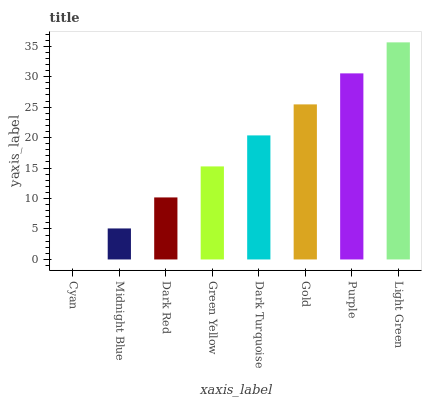Is Cyan the minimum?
Answer yes or no. Yes. Is Light Green the maximum?
Answer yes or no. Yes. Is Midnight Blue the minimum?
Answer yes or no. No. Is Midnight Blue the maximum?
Answer yes or no. No. Is Midnight Blue greater than Cyan?
Answer yes or no. Yes. Is Cyan less than Midnight Blue?
Answer yes or no. Yes. Is Cyan greater than Midnight Blue?
Answer yes or no. No. Is Midnight Blue less than Cyan?
Answer yes or no. No. Is Dark Turquoise the high median?
Answer yes or no. Yes. Is Green Yellow the low median?
Answer yes or no. Yes. Is Purple the high median?
Answer yes or no. No. Is Midnight Blue the low median?
Answer yes or no. No. 